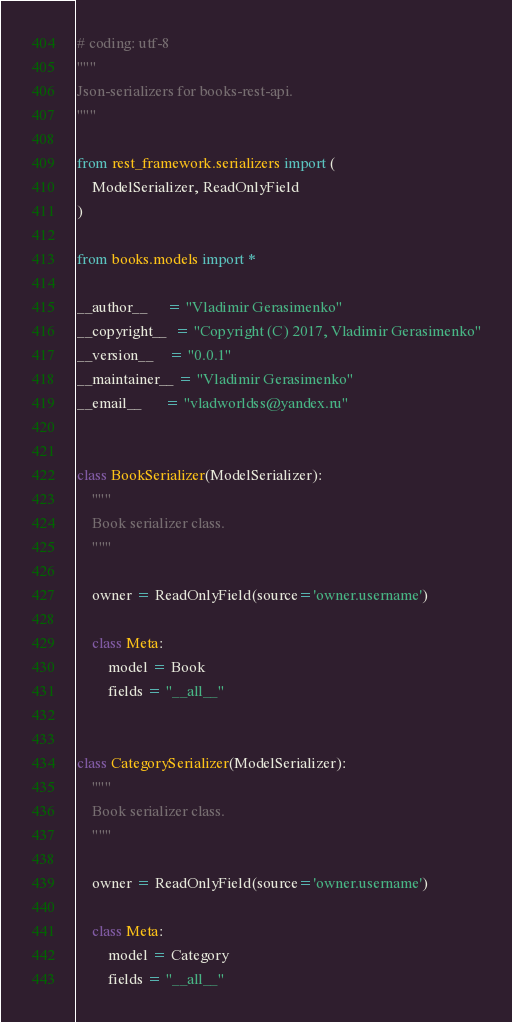<code> <loc_0><loc_0><loc_500><loc_500><_Python_># coding: utf-8
"""
Json-serializers for books-rest-api.
"""

from rest_framework.serializers import (
    ModelSerializer, ReadOnlyField
)

from books.models import *

__author__     = "Vladimir Gerasimenko"
__copyright__  = "Copyright (C) 2017, Vladimir Gerasimenko"
__version__    = "0.0.1"
__maintainer__ = "Vladimir Gerasimenko"
__email__      = "vladworldss@yandex.ru"


class BookSerializer(ModelSerializer):
    """
    Book serializer class.
    """

    owner = ReadOnlyField(source='owner.username')

    class Meta:
        model = Book
        fields = "__all__"


class CategorySerializer(ModelSerializer):
    """
    Book serializer class.
    """

    owner = ReadOnlyField(source='owner.username')

    class Meta:
        model = Category
        fields = "__all__"
</code> 